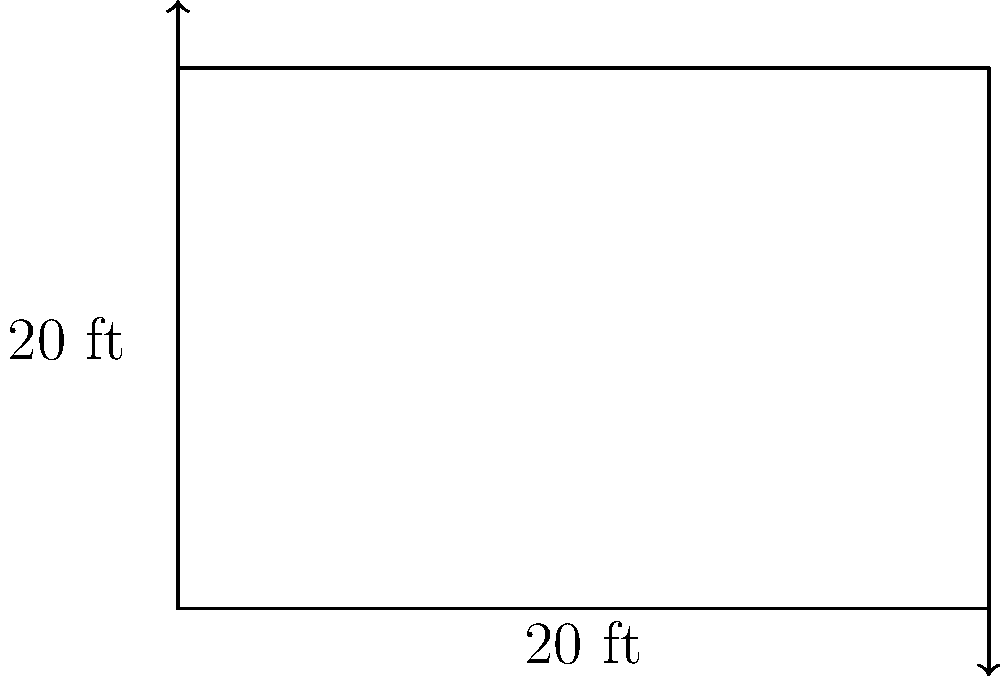As a fashion-forward wrestling enthusiast, you're designing a custom mat for a standard wrestling ring. Given that the ring is a perfect square with sides measuring 20 feet, calculate the total area of the mat you'll need to cover the entire ring. How many square feet of fabric will you need to create your stylish ring cover? Let's approach this step-by-step:

1) First, we need to identify the shape of the wrestling ring. From the diagram, we can see it's a square.

2) We're given that each side of the square measures 20 feet.

3) To calculate the area of a square, we use the formula:

   $$ A = s^2 $$

   Where $A$ is the area and $s$ is the length of a side.

4) Substituting our known value:

   $$ A = 20^2 $$

5) Now, let's calculate:

   $$ A = 20 \times 20 = 400 $$

Therefore, the area of the wrestling ring is 400 square feet.
Answer: 400 sq ft 